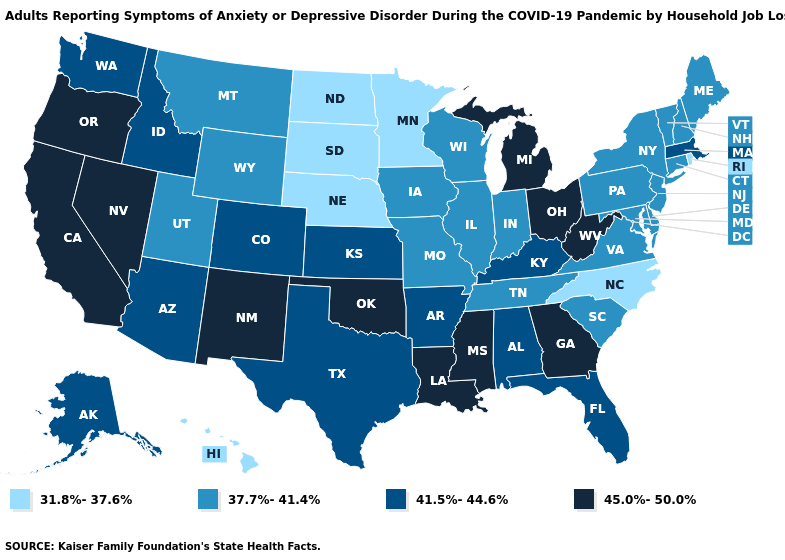What is the value of Washington?
Give a very brief answer. 41.5%-44.6%. What is the lowest value in the USA?
Keep it brief. 31.8%-37.6%. What is the value of Texas?
Keep it brief. 41.5%-44.6%. Does Tennessee have a lower value than Indiana?
Short answer required. No. Does Texas have a lower value than Louisiana?
Quick response, please. Yes. Does the map have missing data?
Answer briefly. No. What is the value of Florida?
Quick response, please. 41.5%-44.6%. What is the highest value in the USA?
Quick response, please. 45.0%-50.0%. Among the states that border South Carolina , which have the highest value?
Keep it brief. Georgia. What is the highest value in states that border Florida?
Give a very brief answer. 45.0%-50.0%. Name the states that have a value in the range 41.5%-44.6%?
Write a very short answer. Alabama, Alaska, Arizona, Arkansas, Colorado, Florida, Idaho, Kansas, Kentucky, Massachusetts, Texas, Washington. What is the highest value in the West ?
Keep it brief. 45.0%-50.0%. What is the highest value in states that border Oregon?
Give a very brief answer. 45.0%-50.0%. Among the states that border Arkansas , does Oklahoma have the highest value?
Write a very short answer. Yes. What is the value of Maryland?
Answer briefly. 37.7%-41.4%. 